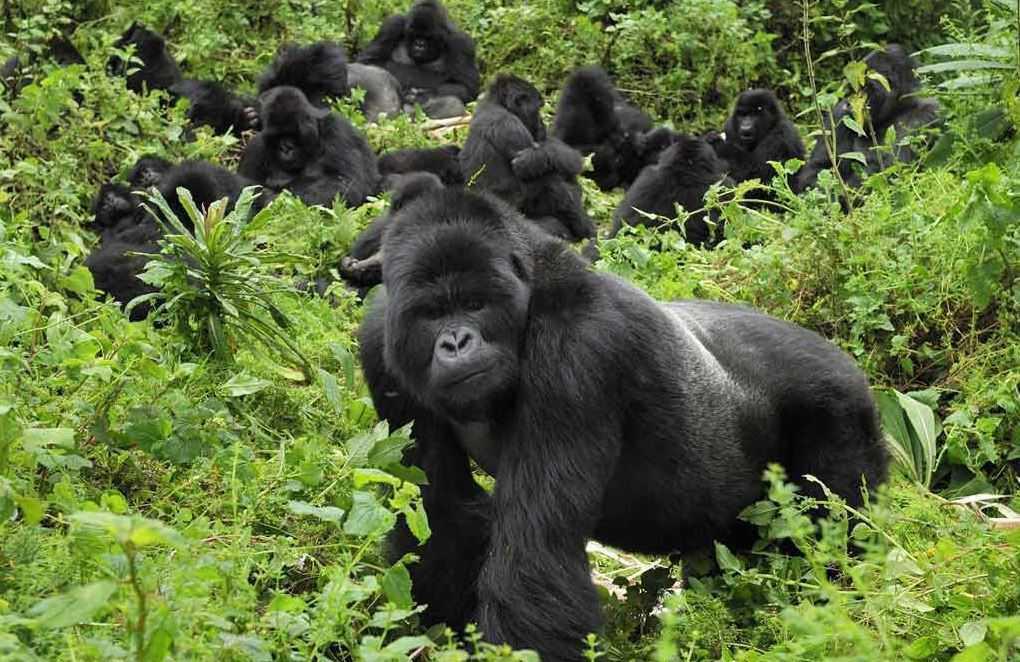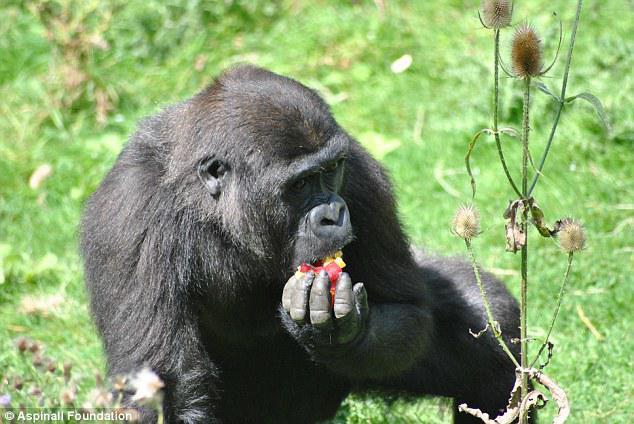The first image is the image on the left, the second image is the image on the right. Considering the images on both sides, is "The right photo shows an adult gorilla interacting with a human being" valid? Answer yes or no. No. The first image is the image on the left, the second image is the image on the right. For the images displayed, is the sentence "An image features one person gazing into the face of a large ape." factually correct? Answer yes or no. No. 